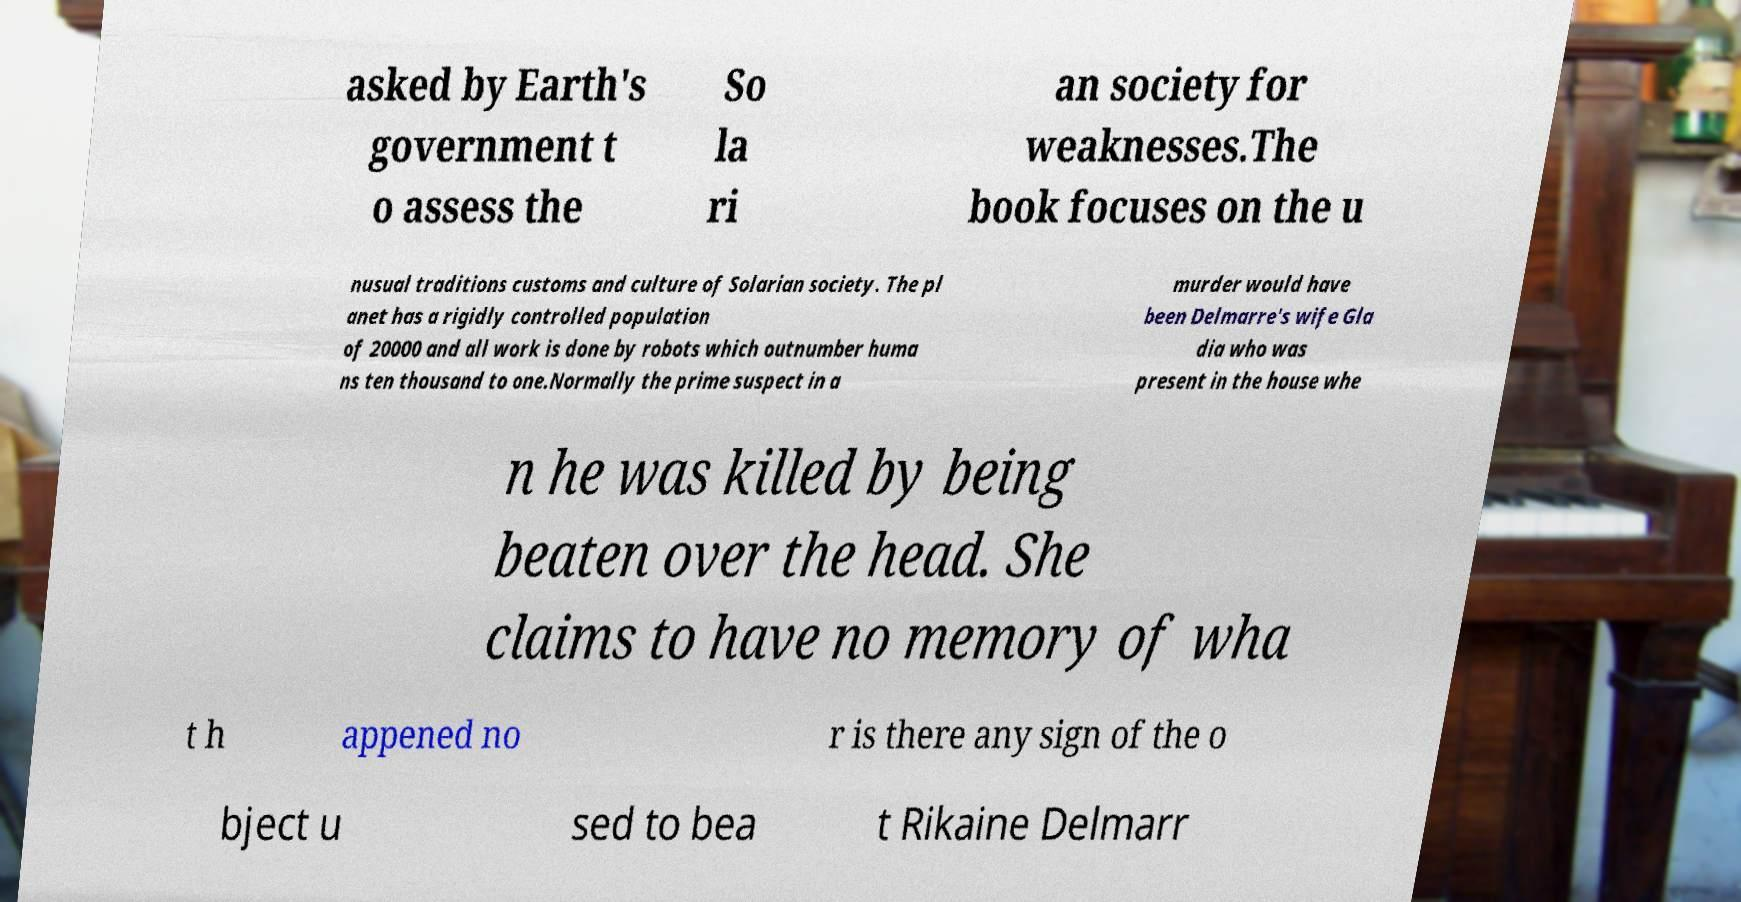I need the written content from this picture converted into text. Can you do that? asked by Earth's government t o assess the So la ri an society for weaknesses.The book focuses on the u nusual traditions customs and culture of Solarian society. The pl anet has a rigidly controlled population of 20000 and all work is done by robots which outnumber huma ns ten thousand to one.Normally the prime suspect in a murder would have been Delmarre's wife Gla dia who was present in the house whe n he was killed by being beaten over the head. She claims to have no memory of wha t h appened no r is there any sign of the o bject u sed to bea t Rikaine Delmarr 